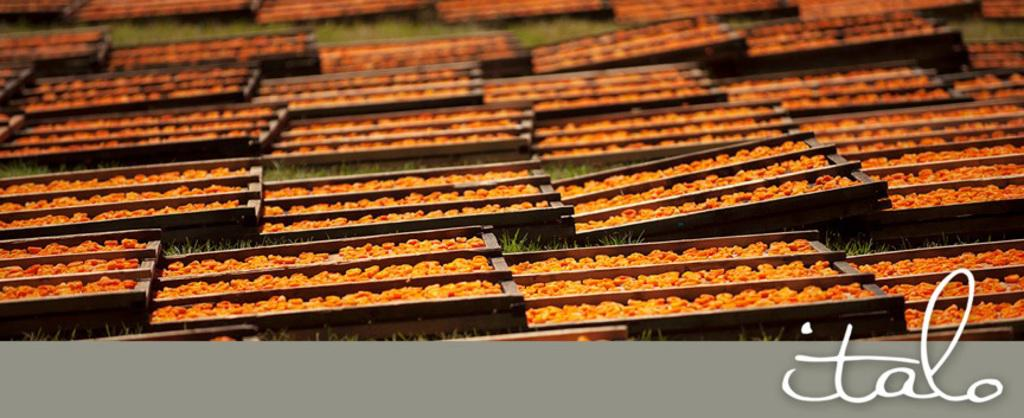What type of surface is visible in the image? There is a grass surface in the image. What is placed on the grass surface? The grass surface has trays on it. What is inside the trays? The trays contain grains. Where can the toothbrush be found in the image? There is no toothbrush present in the image. What level of the building is the grass surface located on? The provided facts do not mention a building or any levels, so it cannot be determined from the image. 